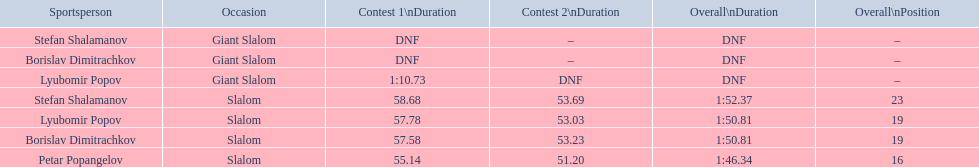What is the number of athletes to finish race one in the giant slalom? 1. 